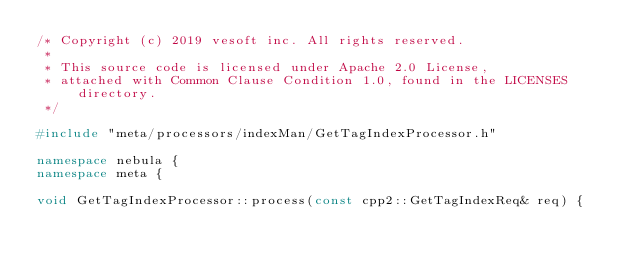<code> <loc_0><loc_0><loc_500><loc_500><_C++_>/* Copyright (c) 2019 vesoft inc. All rights reserved.
 *
 * This source code is licensed under Apache 2.0 License,
 * attached with Common Clause Condition 1.0, found in the LICENSES directory.
 */

#include "meta/processors/indexMan/GetTagIndexProcessor.h"

namespace nebula {
namespace meta {

void GetTagIndexProcessor::process(const cpp2::GetTagIndexReq& req) {</code> 